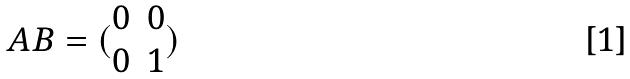Convert formula to latex. <formula><loc_0><loc_0><loc_500><loc_500>A B = ( \begin{matrix} 0 & 0 \\ 0 & 1 \end{matrix} )</formula> 